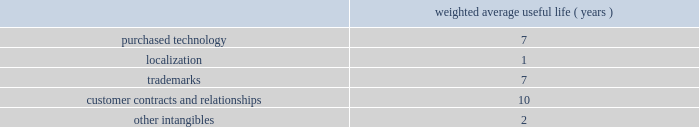Adobe systems incorporated notes to consolidated financial statements ( continued ) foreign currency translation we translate assets and liabilities of foreign subsidiaries , whose functional currency is their local currency , at exchange rates in effect at the balance sheet date .
We translate revenue and expenses at the monthly average exchange rates .
We include accumulated net translation adjustments in stockholders 2019 equity as a component of accumulated other comprehensive income .
Property and equipment we record property and equipment at cost less accumulated depreciation and amortization .
Property and equipment are depreciated using the straight-line method over their estimated useful lives ranging from 1 to 5 years for computers and equipment , 1 to 6 years for furniture and fixtures and up to 35 years for buildings .
Leasehold improvements are amortized using the straight-line method over the lesser of the remaining respective lease term or useful lives .
Goodwill , purchased intangibles and other long-lived assets we review our goodwill for impairment annually , or more frequently , if facts and circumstances warrant a review .
We completed our annual impairment test in the second quarter of fiscal 2009 and determined that there was no impairment .
Goodwill is assigned to one or more reporting segments on the date of acquisition .
We evaluate goodwill for impairment by comparing the fair value of each of our reporting segments to its carrying value , including the associated goodwill .
To determine the fair values , we use the market approach based on comparable publicly traded companies in similar lines of businesses and the income approach based on estimated discounted future cash flows .
Our cash flow assumptions consider historical and forecasted revenue , operating costs and other relevant factors .
We amortize intangible assets with finite lives over their estimated useful lives and review them for impairment whenever an impairment indicator exists .
We continually monitor events and changes in circumstances that could indicate carrying amounts of our long-lived assets , including our intangible assets may not be recoverable .
When such events or changes in circumstances occur , we assess recoverability by determining whether the carrying value of such assets will be recovered through the undiscounted expected future cash flows .
If the future undiscounted cash flows are less than the carrying amount of these assets , we recognize an impairment loss based on the excess of the carrying amount over the fair value of the assets .
We did not recognize any intangible asset impairment charges in fiscal 2009 , 2008 or 2007 .
Our intangible assets are amortized over their estimated useful lives of 1 to 13 years as shown in the table below .
Amortization is based on the pattern in which the economic benefits of the intangible asset will be consumed .
Weighted average useful life ( years ) .
Software development costs capitalization of software development costs for software to be sold , leased , or otherwise marketed begins upon the establishment of technological feasibility , which is generally the completion of a working prototype that has been certified as having no critical bugs and is a release candidate .
Amortization begins once the software is ready for its intended use , generally based on the pattern in which the economic benefits will be consumed .
To date , software development costs incurred between completion of a working prototype and general availability of the related product have not been material .
Revenue recognition our revenue is derived from the licensing of software products , consulting , hosting services and maintenance and support .
Primarily , we recognize revenue when persuasive evidence of an arrangement exists , we have delivered the product or performed the service , the fee is fixed or determinable and collection is probable. .
For the weighted average useful life ( years ) of intangibles , was the life of purchased technology greater than localization? 
Computations: (7 > 1)
Answer: yes. 